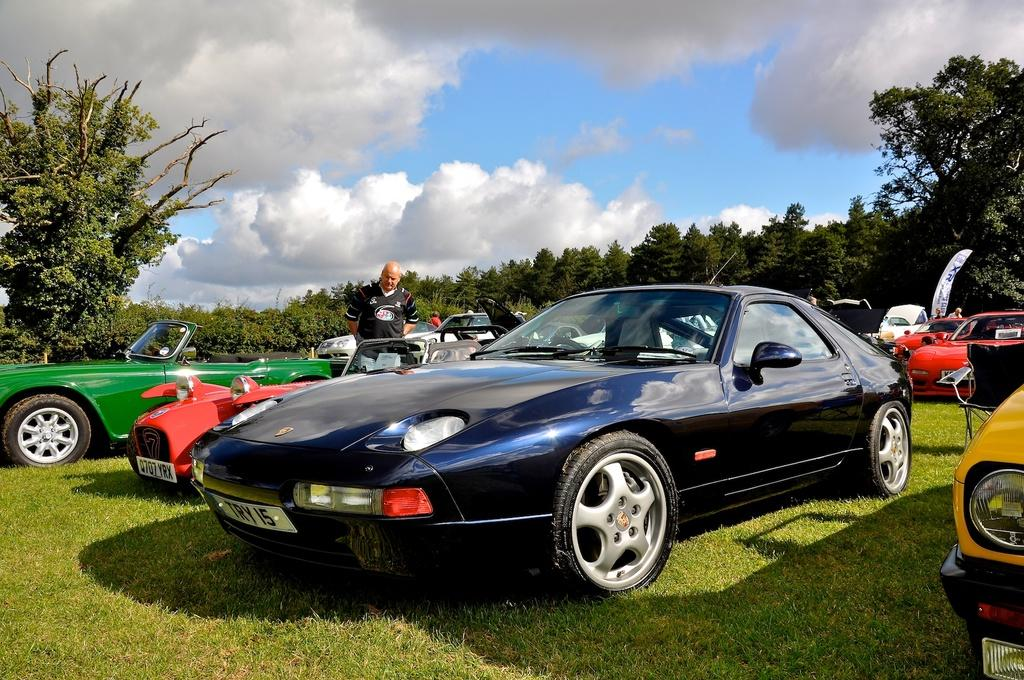What type of vehicles are on the grass in the image? There are motor vehicles on the grass in the image. Can you describe the person's position in relation to the vehicles? A person is standing between the motor vehicles. What can be seen in the background of the image? Sky and trees are visible in the background of the image. What is the condition of the sky in the image? Clouds are present in the sky. What type of curve can be seen in the field in the image? There is no field present in the image, and therefore no curve can be observed. 